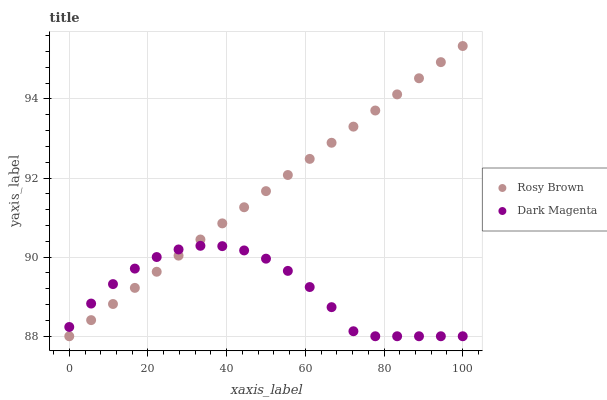Does Dark Magenta have the minimum area under the curve?
Answer yes or no. Yes. Does Rosy Brown have the maximum area under the curve?
Answer yes or no. Yes. Does Dark Magenta have the maximum area under the curve?
Answer yes or no. No. Is Rosy Brown the smoothest?
Answer yes or no. Yes. Is Dark Magenta the roughest?
Answer yes or no. Yes. Is Dark Magenta the smoothest?
Answer yes or no. No. Does Rosy Brown have the lowest value?
Answer yes or no. Yes. Does Rosy Brown have the highest value?
Answer yes or no. Yes. Does Dark Magenta have the highest value?
Answer yes or no. No. Does Rosy Brown intersect Dark Magenta?
Answer yes or no. Yes. Is Rosy Brown less than Dark Magenta?
Answer yes or no. No. Is Rosy Brown greater than Dark Magenta?
Answer yes or no. No. 